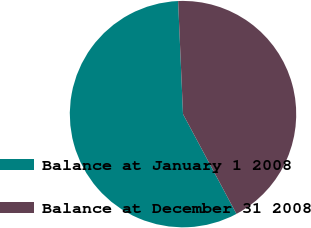<chart> <loc_0><loc_0><loc_500><loc_500><pie_chart><fcel>Balance at January 1 2008<fcel>Balance at December 31 2008<nl><fcel>57.14%<fcel>42.86%<nl></chart> 